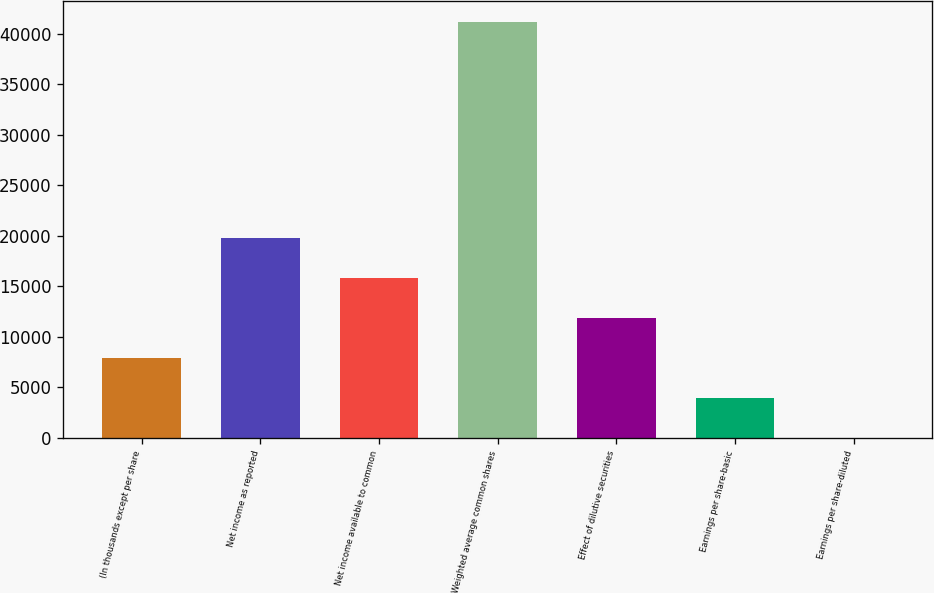<chart> <loc_0><loc_0><loc_500><loc_500><bar_chart><fcel>(In thousands except per share<fcel>Net income as reported<fcel>Net income available to common<fcel>Weighted average common shares<fcel>Effect of dilutive securities<fcel>Earnings per share-basic<fcel>Earnings per share-diluted<nl><fcel>7937.48<fcel>19843.2<fcel>15874.6<fcel>41167.6<fcel>11906<fcel>3968.92<fcel>0.36<nl></chart> 